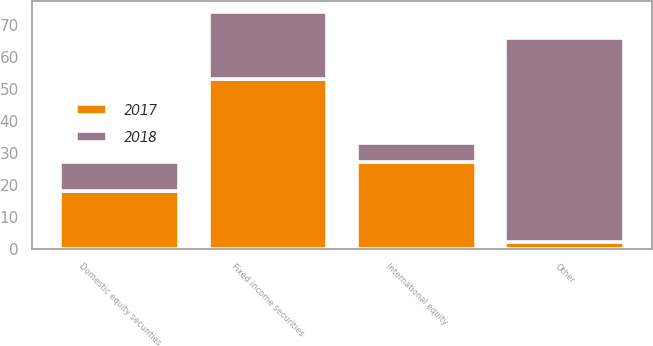Convert chart to OTSL. <chart><loc_0><loc_0><loc_500><loc_500><stacked_bar_chart><ecel><fcel>Fixed income securities<fcel>International equity<fcel>Domestic equity securities<fcel>Other<nl><fcel>2017<fcel>53<fcel>27<fcel>18<fcel>2<nl><fcel>2018<fcel>21<fcel>6<fcel>9<fcel>64<nl></chart> 